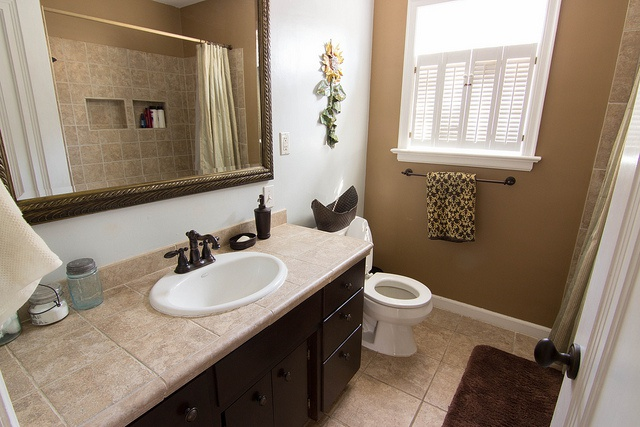Describe the objects in this image and their specific colors. I can see sink in lightgray and darkgray tones, toilet in lightgray and gray tones, bowl in lightgray, black, and gray tones, bottle in lightgray, black, gray, and darkgray tones, and bottle in lightgray, gray, darkgray, and black tones in this image. 